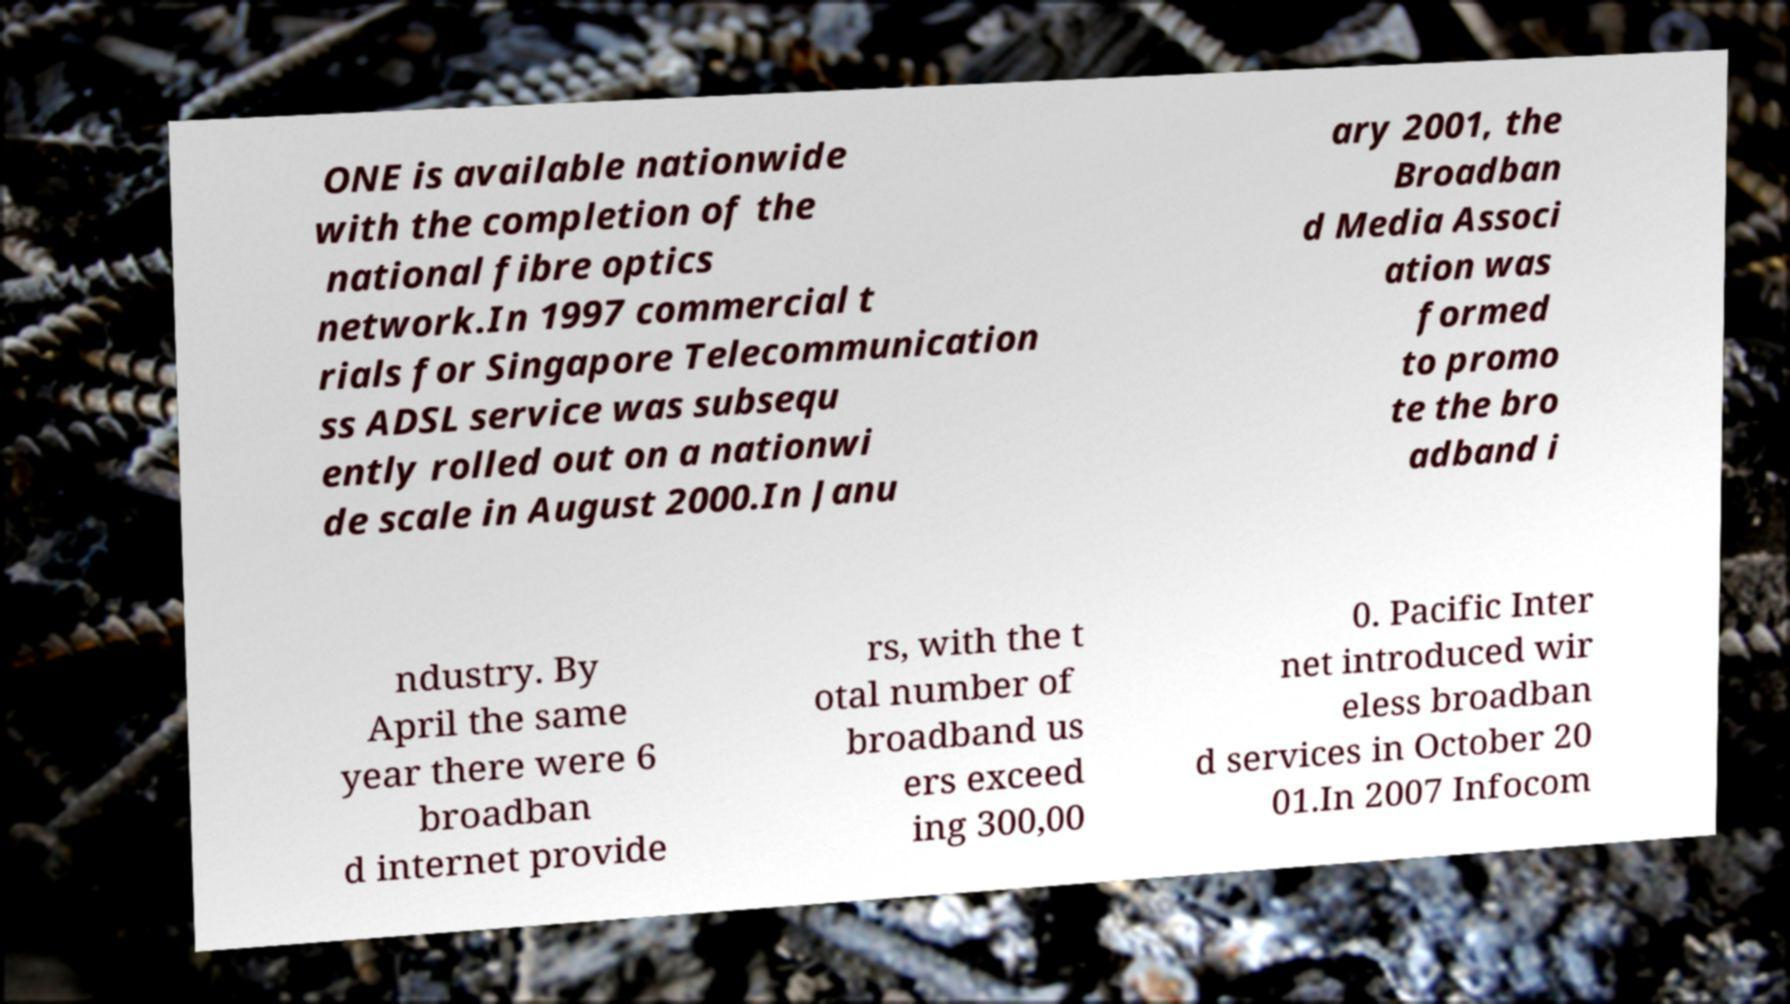There's text embedded in this image that I need extracted. Can you transcribe it verbatim? ONE is available nationwide with the completion of the national fibre optics network.In 1997 commercial t rials for Singapore Telecommunication ss ADSL service was subsequ ently rolled out on a nationwi de scale in August 2000.In Janu ary 2001, the Broadban d Media Associ ation was formed to promo te the bro adband i ndustry. By April the same year there were 6 broadban d internet provide rs, with the t otal number of broadband us ers exceed ing 300,00 0. Pacific Inter net introduced wir eless broadban d services in October 20 01.In 2007 Infocom 